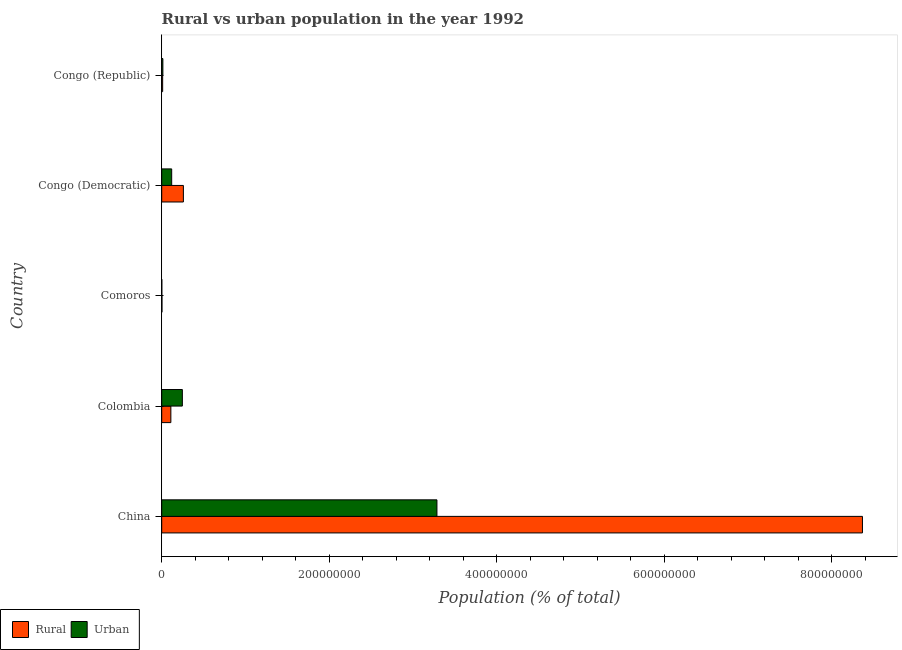How many different coloured bars are there?
Your answer should be compact. 2. How many groups of bars are there?
Ensure brevity in your answer.  5. Are the number of bars per tick equal to the number of legend labels?
Provide a succinct answer. Yes. How many bars are there on the 4th tick from the top?
Make the answer very short. 2. What is the label of the 4th group of bars from the top?
Offer a terse response. Colombia. In how many cases, is the number of bars for a given country not equal to the number of legend labels?
Provide a succinct answer. 0. What is the urban population density in China?
Ensure brevity in your answer.  3.29e+08. Across all countries, what is the maximum urban population density?
Offer a terse response. 3.29e+08. Across all countries, what is the minimum rural population density?
Provide a short and direct response. 3.15e+05. In which country was the urban population density minimum?
Offer a very short reply. Comoros. What is the total rural population density in the graph?
Give a very brief answer. 8.75e+08. What is the difference between the urban population density in Colombia and that in Comoros?
Keep it short and to the point. 2.45e+07. What is the difference between the rural population density in China and the urban population density in Congo (Democratic)?
Make the answer very short. 8.25e+08. What is the average urban population density per country?
Ensure brevity in your answer.  7.33e+07. What is the difference between the urban population density and rural population density in Colombia?
Keep it short and to the point. 1.37e+07. In how many countries, is the urban population density greater than 320000000 %?
Ensure brevity in your answer.  1. What is the ratio of the urban population density in Comoros to that in Congo (Republic)?
Give a very brief answer. 0.09. Is the urban population density in Colombia less than that in Comoros?
Give a very brief answer. No. What is the difference between the highest and the second highest rural population density?
Your answer should be compact. 8.11e+08. What is the difference between the highest and the lowest urban population density?
Provide a short and direct response. 3.28e+08. Is the sum of the urban population density in Comoros and Congo (Republic) greater than the maximum rural population density across all countries?
Provide a short and direct response. No. What does the 1st bar from the top in Congo (Democratic) represents?
Give a very brief answer. Urban. What does the 1st bar from the bottom in Comoros represents?
Your response must be concise. Rural. Are all the bars in the graph horizontal?
Keep it short and to the point. Yes. What is the difference between two consecutive major ticks on the X-axis?
Provide a succinct answer. 2.00e+08. How are the legend labels stacked?
Give a very brief answer. Horizontal. What is the title of the graph?
Provide a succinct answer. Rural vs urban population in the year 1992. Does "Commercial bank branches" appear as one of the legend labels in the graph?
Your answer should be compact. No. What is the label or title of the X-axis?
Offer a terse response. Population (% of total). What is the Population (% of total) of Rural in China?
Provide a succinct answer. 8.36e+08. What is the Population (% of total) of Urban in China?
Provide a succinct answer. 3.29e+08. What is the Population (% of total) of Rural in Colombia?
Your response must be concise. 1.09e+07. What is the Population (% of total) of Urban in Colombia?
Provide a short and direct response. 2.46e+07. What is the Population (% of total) in Rural in Comoros?
Provide a succinct answer. 3.15e+05. What is the Population (% of total) in Urban in Comoros?
Offer a terse response. 1.25e+05. What is the Population (% of total) of Rural in Congo (Democratic)?
Ensure brevity in your answer.  2.59e+07. What is the Population (% of total) of Urban in Congo (Democratic)?
Provide a succinct answer. 1.19e+07. What is the Population (% of total) in Rural in Congo (Republic)?
Provide a short and direct response. 1.13e+06. What is the Population (% of total) of Urban in Congo (Republic)?
Make the answer very short. 1.39e+06. Across all countries, what is the maximum Population (% of total) of Rural?
Give a very brief answer. 8.36e+08. Across all countries, what is the maximum Population (% of total) in Urban?
Provide a succinct answer. 3.29e+08. Across all countries, what is the minimum Population (% of total) of Rural?
Offer a very short reply. 3.15e+05. Across all countries, what is the minimum Population (% of total) in Urban?
Keep it short and to the point. 1.25e+05. What is the total Population (% of total) in Rural in the graph?
Give a very brief answer. 8.75e+08. What is the total Population (% of total) in Urban in the graph?
Make the answer very short. 3.67e+08. What is the difference between the Population (% of total) of Rural in China and that in Colombia?
Make the answer very short. 8.26e+08. What is the difference between the Population (% of total) of Urban in China and that in Colombia?
Keep it short and to the point. 3.04e+08. What is the difference between the Population (% of total) of Rural in China and that in Comoros?
Your answer should be very brief. 8.36e+08. What is the difference between the Population (% of total) in Urban in China and that in Comoros?
Your answer should be very brief. 3.28e+08. What is the difference between the Population (% of total) in Rural in China and that in Congo (Democratic)?
Offer a very short reply. 8.11e+08. What is the difference between the Population (% of total) of Urban in China and that in Congo (Democratic)?
Your response must be concise. 3.17e+08. What is the difference between the Population (% of total) in Rural in China and that in Congo (Republic)?
Offer a very short reply. 8.35e+08. What is the difference between the Population (% of total) in Urban in China and that in Congo (Republic)?
Provide a succinct answer. 3.27e+08. What is the difference between the Population (% of total) in Rural in Colombia and that in Comoros?
Ensure brevity in your answer.  1.06e+07. What is the difference between the Population (% of total) in Urban in Colombia and that in Comoros?
Your response must be concise. 2.45e+07. What is the difference between the Population (% of total) in Rural in Colombia and that in Congo (Democratic)?
Your answer should be very brief. -1.50e+07. What is the difference between the Population (% of total) of Urban in Colombia and that in Congo (Democratic)?
Offer a terse response. 1.27e+07. What is the difference between the Population (% of total) of Rural in Colombia and that in Congo (Republic)?
Ensure brevity in your answer.  9.78e+06. What is the difference between the Population (% of total) in Urban in Colombia and that in Congo (Republic)?
Provide a succinct answer. 2.33e+07. What is the difference between the Population (% of total) of Rural in Comoros and that in Congo (Democratic)?
Provide a succinct answer. -2.56e+07. What is the difference between the Population (% of total) in Urban in Comoros and that in Congo (Democratic)?
Make the answer very short. -1.18e+07. What is the difference between the Population (% of total) in Rural in Comoros and that in Congo (Republic)?
Keep it short and to the point. -8.13e+05. What is the difference between the Population (% of total) in Urban in Comoros and that in Congo (Republic)?
Ensure brevity in your answer.  -1.26e+06. What is the difference between the Population (% of total) in Rural in Congo (Democratic) and that in Congo (Republic)?
Give a very brief answer. 2.48e+07. What is the difference between the Population (% of total) in Urban in Congo (Democratic) and that in Congo (Republic)?
Offer a terse response. 1.05e+07. What is the difference between the Population (% of total) of Rural in China and the Population (% of total) of Urban in Colombia?
Make the answer very short. 8.12e+08. What is the difference between the Population (% of total) of Rural in China and the Population (% of total) of Urban in Comoros?
Give a very brief answer. 8.36e+08. What is the difference between the Population (% of total) of Rural in China and the Population (% of total) of Urban in Congo (Democratic)?
Make the answer very short. 8.25e+08. What is the difference between the Population (% of total) of Rural in China and the Population (% of total) of Urban in Congo (Republic)?
Give a very brief answer. 8.35e+08. What is the difference between the Population (% of total) in Rural in Colombia and the Population (% of total) in Urban in Comoros?
Your answer should be very brief. 1.08e+07. What is the difference between the Population (% of total) in Rural in Colombia and the Population (% of total) in Urban in Congo (Democratic)?
Ensure brevity in your answer.  -9.92e+05. What is the difference between the Population (% of total) of Rural in Colombia and the Population (% of total) of Urban in Congo (Republic)?
Your response must be concise. 9.53e+06. What is the difference between the Population (% of total) of Rural in Comoros and the Population (% of total) of Urban in Congo (Democratic)?
Ensure brevity in your answer.  -1.16e+07. What is the difference between the Population (% of total) in Rural in Comoros and the Population (% of total) in Urban in Congo (Republic)?
Make the answer very short. -1.07e+06. What is the difference between the Population (% of total) of Rural in Congo (Democratic) and the Population (% of total) of Urban in Congo (Republic)?
Offer a terse response. 2.45e+07. What is the average Population (% of total) of Rural per country?
Your answer should be compact. 1.75e+08. What is the average Population (% of total) in Urban per country?
Make the answer very short. 7.33e+07. What is the difference between the Population (% of total) of Rural and Population (% of total) of Urban in China?
Offer a terse response. 5.08e+08. What is the difference between the Population (% of total) of Rural and Population (% of total) of Urban in Colombia?
Make the answer very short. -1.37e+07. What is the difference between the Population (% of total) of Rural and Population (% of total) of Urban in Comoros?
Keep it short and to the point. 1.90e+05. What is the difference between the Population (% of total) in Rural and Population (% of total) in Urban in Congo (Democratic)?
Provide a short and direct response. 1.40e+07. What is the difference between the Population (% of total) in Rural and Population (% of total) in Urban in Congo (Republic)?
Give a very brief answer. -2.60e+05. What is the ratio of the Population (% of total) in Rural in China to that in Colombia?
Provide a short and direct response. 76.65. What is the ratio of the Population (% of total) of Urban in China to that in Colombia?
Keep it short and to the point. 13.33. What is the ratio of the Population (% of total) of Rural in China to that in Comoros?
Your response must be concise. 2654.84. What is the ratio of the Population (% of total) of Urban in China to that in Comoros?
Make the answer very short. 2624.27. What is the ratio of the Population (% of total) of Rural in China to that in Congo (Democratic)?
Make the answer very short. 32.32. What is the ratio of the Population (% of total) in Urban in China to that in Congo (Democratic)?
Provide a short and direct response. 27.6. What is the ratio of the Population (% of total) of Rural in China to that in Congo (Republic)?
Your response must be concise. 741.77. What is the ratio of the Population (% of total) of Urban in China to that in Congo (Republic)?
Your answer should be compact. 236.81. What is the ratio of the Population (% of total) in Rural in Colombia to that in Comoros?
Ensure brevity in your answer.  34.64. What is the ratio of the Population (% of total) in Urban in Colombia to that in Comoros?
Offer a terse response. 196.88. What is the ratio of the Population (% of total) in Rural in Colombia to that in Congo (Democratic)?
Provide a succinct answer. 0.42. What is the ratio of the Population (% of total) of Urban in Colombia to that in Congo (Democratic)?
Your response must be concise. 2.07. What is the ratio of the Population (% of total) of Rural in Colombia to that in Congo (Republic)?
Ensure brevity in your answer.  9.68. What is the ratio of the Population (% of total) of Urban in Colombia to that in Congo (Republic)?
Your answer should be compact. 17.77. What is the ratio of the Population (% of total) of Rural in Comoros to that in Congo (Democratic)?
Provide a short and direct response. 0.01. What is the ratio of the Population (% of total) of Urban in Comoros to that in Congo (Democratic)?
Your response must be concise. 0.01. What is the ratio of the Population (% of total) of Rural in Comoros to that in Congo (Republic)?
Ensure brevity in your answer.  0.28. What is the ratio of the Population (% of total) of Urban in Comoros to that in Congo (Republic)?
Offer a very short reply. 0.09. What is the ratio of the Population (% of total) of Rural in Congo (Democratic) to that in Congo (Republic)?
Your answer should be very brief. 22.95. What is the ratio of the Population (% of total) in Urban in Congo (Democratic) to that in Congo (Republic)?
Your response must be concise. 8.58. What is the difference between the highest and the second highest Population (% of total) in Rural?
Your answer should be very brief. 8.11e+08. What is the difference between the highest and the second highest Population (% of total) of Urban?
Your response must be concise. 3.04e+08. What is the difference between the highest and the lowest Population (% of total) in Rural?
Your response must be concise. 8.36e+08. What is the difference between the highest and the lowest Population (% of total) of Urban?
Your answer should be compact. 3.28e+08. 